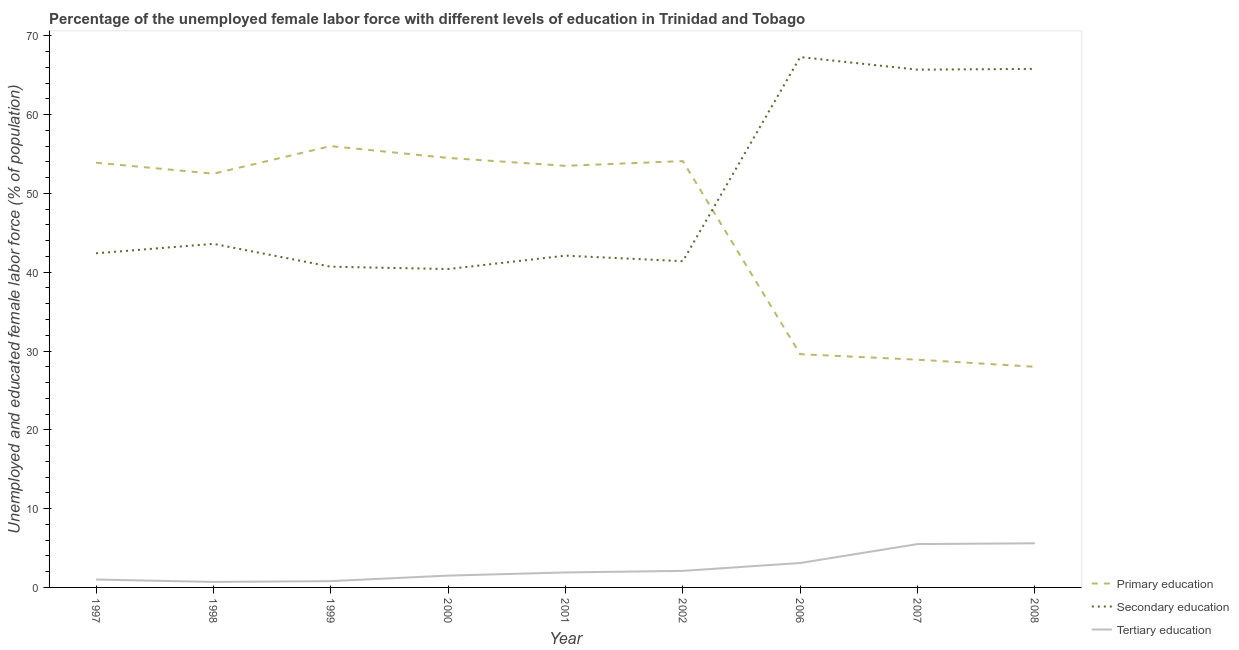How many different coloured lines are there?
Offer a terse response. 3. Does the line corresponding to percentage of female labor force who received tertiary education intersect with the line corresponding to percentage of female labor force who received primary education?
Make the answer very short. No. What is the percentage of female labor force who received tertiary education in 2001?
Give a very brief answer. 1.9. Across all years, what is the maximum percentage of female labor force who received secondary education?
Keep it short and to the point. 67.3. Across all years, what is the minimum percentage of female labor force who received tertiary education?
Keep it short and to the point. 0.7. In which year was the percentage of female labor force who received primary education maximum?
Provide a short and direct response. 1999. In which year was the percentage of female labor force who received secondary education minimum?
Provide a succinct answer. 2000. What is the total percentage of female labor force who received secondary education in the graph?
Ensure brevity in your answer.  449.4. What is the difference between the percentage of female labor force who received tertiary education in 1997 and that in 2007?
Your response must be concise. -4.5. What is the difference between the percentage of female labor force who received secondary education in 2007 and the percentage of female labor force who received primary education in 2001?
Give a very brief answer. 12.2. What is the average percentage of female labor force who received secondary education per year?
Your response must be concise. 49.93. In the year 2000, what is the difference between the percentage of female labor force who received primary education and percentage of female labor force who received secondary education?
Your answer should be very brief. 14.1. What is the ratio of the percentage of female labor force who received tertiary education in 1997 to that in 2001?
Provide a succinct answer. 0.53. Is the percentage of female labor force who received primary education in 1999 less than that in 2007?
Provide a succinct answer. No. What is the difference between the highest and the second highest percentage of female labor force who received secondary education?
Your answer should be very brief. 1.5. What is the difference between the highest and the lowest percentage of female labor force who received secondary education?
Provide a succinct answer. 26.9. In how many years, is the percentage of female labor force who received tertiary education greater than the average percentage of female labor force who received tertiary education taken over all years?
Offer a terse response. 3. Is it the case that in every year, the sum of the percentage of female labor force who received primary education and percentage of female labor force who received secondary education is greater than the percentage of female labor force who received tertiary education?
Your answer should be very brief. Yes. Is the percentage of female labor force who received tertiary education strictly greater than the percentage of female labor force who received primary education over the years?
Make the answer very short. No. Is the percentage of female labor force who received secondary education strictly less than the percentage of female labor force who received primary education over the years?
Provide a short and direct response. No. How many lines are there?
Give a very brief answer. 3. How many years are there in the graph?
Provide a short and direct response. 9. What is the difference between two consecutive major ticks on the Y-axis?
Ensure brevity in your answer.  10. Are the values on the major ticks of Y-axis written in scientific E-notation?
Provide a short and direct response. No. Where does the legend appear in the graph?
Your answer should be very brief. Bottom right. How many legend labels are there?
Your response must be concise. 3. What is the title of the graph?
Keep it short and to the point. Percentage of the unemployed female labor force with different levels of education in Trinidad and Tobago. What is the label or title of the Y-axis?
Provide a succinct answer. Unemployed and educated female labor force (% of population). What is the Unemployed and educated female labor force (% of population) of Primary education in 1997?
Your answer should be very brief. 53.9. What is the Unemployed and educated female labor force (% of population) in Secondary education in 1997?
Keep it short and to the point. 42.4. What is the Unemployed and educated female labor force (% of population) of Primary education in 1998?
Provide a short and direct response. 52.5. What is the Unemployed and educated female labor force (% of population) of Secondary education in 1998?
Make the answer very short. 43.6. What is the Unemployed and educated female labor force (% of population) of Tertiary education in 1998?
Ensure brevity in your answer.  0.7. What is the Unemployed and educated female labor force (% of population) of Primary education in 1999?
Give a very brief answer. 56. What is the Unemployed and educated female labor force (% of population) of Secondary education in 1999?
Give a very brief answer. 40.7. What is the Unemployed and educated female labor force (% of population) of Tertiary education in 1999?
Offer a terse response. 0.8. What is the Unemployed and educated female labor force (% of population) of Primary education in 2000?
Provide a short and direct response. 54.5. What is the Unemployed and educated female labor force (% of population) in Secondary education in 2000?
Make the answer very short. 40.4. What is the Unemployed and educated female labor force (% of population) in Tertiary education in 2000?
Your answer should be compact. 1.5. What is the Unemployed and educated female labor force (% of population) of Primary education in 2001?
Offer a very short reply. 53.5. What is the Unemployed and educated female labor force (% of population) in Secondary education in 2001?
Offer a terse response. 42.1. What is the Unemployed and educated female labor force (% of population) of Tertiary education in 2001?
Your answer should be compact. 1.9. What is the Unemployed and educated female labor force (% of population) of Primary education in 2002?
Provide a short and direct response. 54.1. What is the Unemployed and educated female labor force (% of population) in Secondary education in 2002?
Provide a short and direct response. 41.4. What is the Unemployed and educated female labor force (% of population) of Tertiary education in 2002?
Provide a succinct answer. 2.1. What is the Unemployed and educated female labor force (% of population) of Primary education in 2006?
Provide a succinct answer. 29.6. What is the Unemployed and educated female labor force (% of population) of Secondary education in 2006?
Make the answer very short. 67.3. What is the Unemployed and educated female labor force (% of population) in Tertiary education in 2006?
Provide a short and direct response. 3.1. What is the Unemployed and educated female labor force (% of population) of Primary education in 2007?
Your response must be concise. 28.9. What is the Unemployed and educated female labor force (% of population) in Secondary education in 2007?
Offer a very short reply. 65.7. What is the Unemployed and educated female labor force (% of population) of Secondary education in 2008?
Provide a short and direct response. 65.8. What is the Unemployed and educated female labor force (% of population) of Tertiary education in 2008?
Offer a terse response. 5.6. Across all years, what is the maximum Unemployed and educated female labor force (% of population) of Secondary education?
Provide a short and direct response. 67.3. Across all years, what is the maximum Unemployed and educated female labor force (% of population) of Tertiary education?
Your response must be concise. 5.6. Across all years, what is the minimum Unemployed and educated female labor force (% of population) in Secondary education?
Offer a terse response. 40.4. Across all years, what is the minimum Unemployed and educated female labor force (% of population) of Tertiary education?
Make the answer very short. 0.7. What is the total Unemployed and educated female labor force (% of population) of Primary education in the graph?
Your answer should be very brief. 411. What is the total Unemployed and educated female labor force (% of population) in Secondary education in the graph?
Make the answer very short. 449.4. What is the difference between the Unemployed and educated female labor force (% of population) in Primary education in 1997 and that in 1998?
Offer a very short reply. 1.4. What is the difference between the Unemployed and educated female labor force (% of population) of Tertiary education in 1997 and that in 1998?
Your answer should be very brief. 0.3. What is the difference between the Unemployed and educated female labor force (% of population) in Tertiary education in 1997 and that in 1999?
Provide a short and direct response. 0.2. What is the difference between the Unemployed and educated female labor force (% of population) in Tertiary education in 1997 and that in 2000?
Offer a very short reply. -0.5. What is the difference between the Unemployed and educated female labor force (% of population) of Primary education in 1997 and that in 2006?
Give a very brief answer. 24.3. What is the difference between the Unemployed and educated female labor force (% of population) of Secondary education in 1997 and that in 2006?
Make the answer very short. -24.9. What is the difference between the Unemployed and educated female labor force (% of population) of Tertiary education in 1997 and that in 2006?
Give a very brief answer. -2.1. What is the difference between the Unemployed and educated female labor force (% of population) in Primary education in 1997 and that in 2007?
Offer a very short reply. 25. What is the difference between the Unemployed and educated female labor force (% of population) in Secondary education in 1997 and that in 2007?
Your answer should be very brief. -23.3. What is the difference between the Unemployed and educated female labor force (% of population) in Tertiary education in 1997 and that in 2007?
Offer a very short reply. -4.5. What is the difference between the Unemployed and educated female labor force (% of population) of Primary education in 1997 and that in 2008?
Offer a very short reply. 25.9. What is the difference between the Unemployed and educated female labor force (% of population) of Secondary education in 1997 and that in 2008?
Make the answer very short. -23.4. What is the difference between the Unemployed and educated female labor force (% of population) of Primary education in 1998 and that in 1999?
Provide a succinct answer. -3.5. What is the difference between the Unemployed and educated female labor force (% of population) of Primary education in 1998 and that in 2000?
Provide a short and direct response. -2. What is the difference between the Unemployed and educated female labor force (% of population) in Secondary education in 1998 and that in 2000?
Offer a terse response. 3.2. What is the difference between the Unemployed and educated female labor force (% of population) in Tertiary education in 1998 and that in 2000?
Keep it short and to the point. -0.8. What is the difference between the Unemployed and educated female labor force (% of population) in Secondary education in 1998 and that in 2001?
Provide a succinct answer. 1.5. What is the difference between the Unemployed and educated female labor force (% of population) of Tertiary education in 1998 and that in 2001?
Provide a short and direct response. -1.2. What is the difference between the Unemployed and educated female labor force (% of population) in Secondary education in 1998 and that in 2002?
Provide a succinct answer. 2.2. What is the difference between the Unemployed and educated female labor force (% of population) of Primary education in 1998 and that in 2006?
Provide a succinct answer. 22.9. What is the difference between the Unemployed and educated female labor force (% of population) of Secondary education in 1998 and that in 2006?
Make the answer very short. -23.7. What is the difference between the Unemployed and educated female labor force (% of population) in Primary education in 1998 and that in 2007?
Your response must be concise. 23.6. What is the difference between the Unemployed and educated female labor force (% of population) in Secondary education in 1998 and that in 2007?
Provide a succinct answer. -22.1. What is the difference between the Unemployed and educated female labor force (% of population) in Tertiary education in 1998 and that in 2007?
Keep it short and to the point. -4.8. What is the difference between the Unemployed and educated female labor force (% of population) of Secondary education in 1998 and that in 2008?
Your answer should be very brief. -22.2. What is the difference between the Unemployed and educated female labor force (% of population) of Primary education in 1999 and that in 2000?
Make the answer very short. 1.5. What is the difference between the Unemployed and educated female labor force (% of population) in Secondary education in 1999 and that in 2000?
Give a very brief answer. 0.3. What is the difference between the Unemployed and educated female labor force (% of population) in Tertiary education in 1999 and that in 2000?
Give a very brief answer. -0.7. What is the difference between the Unemployed and educated female labor force (% of population) of Primary education in 1999 and that in 2001?
Provide a succinct answer. 2.5. What is the difference between the Unemployed and educated female labor force (% of population) of Secondary education in 1999 and that in 2001?
Your response must be concise. -1.4. What is the difference between the Unemployed and educated female labor force (% of population) in Tertiary education in 1999 and that in 2002?
Your response must be concise. -1.3. What is the difference between the Unemployed and educated female labor force (% of population) in Primary education in 1999 and that in 2006?
Provide a short and direct response. 26.4. What is the difference between the Unemployed and educated female labor force (% of population) in Secondary education in 1999 and that in 2006?
Ensure brevity in your answer.  -26.6. What is the difference between the Unemployed and educated female labor force (% of population) in Primary education in 1999 and that in 2007?
Provide a succinct answer. 27.1. What is the difference between the Unemployed and educated female labor force (% of population) of Tertiary education in 1999 and that in 2007?
Your answer should be very brief. -4.7. What is the difference between the Unemployed and educated female labor force (% of population) in Secondary education in 1999 and that in 2008?
Ensure brevity in your answer.  -25.1. What is the difference between the Unemployed and educated female labor force (% of population) in Tertiary education in 1999 and that in 2008?
Keep it short and to the point. -4.8. What is the difference between the Unemployed and educated female labor force (% of population) of Tertiary education in 2000 and that in 2002?
Your response must be concise. -0.6. What is the difference between the Unemployed and educated female labor force (% of population) in Primary education in 2000 and that in 2006?
Provide a succinct answer. 24.9. What is the difference between the Unemployed and educated female labor force (% of population) in Secondary education in 2000 and that in 2006?
Give a very brief answer. -26.9. What is the difference between the Unemployed and educated female labor force (% of population) in Primary education in 2000 and that in 2007?
Make the answer very short. 25.6. What is the difference between the Unemployed and educated female labor force (% of population) of Secondary education in 2000 and that in 2007?
Give a very brief answer. -25.3. What is the difference between the Unemployed and educated female labor force (% of population) of Tertiary education in 2000 and that in 2007?
Offer a terse response. -4. What is the difference between the Unemployed and educated female labor force (% of population) in Primary education in 2000 and that in 2008?
Keep it short and to the point. 26.5. What is the difference between the Unemployed and educated female labor force (% of population) in Secondary education in 2000 and that in 2008?
Offer a very short reply. -25.4. What is the difference between the Unemployed and educated female labor force (% of population) of Primary education in 2001 and that in 2002?
Offer a terse response. -0.6. What is the difference between the Unemployed and educated female labor force (% of population) in Secondary education in 2001 and that in 2002?
Offer a very short reply. 0.7. What is the difference between the Unemployed and educated female labor force (% of population) of Primary education in 2001 and that in 2006?
Give a very brief answer. 23.9. What is the difference between the Unemployed and educated female labor force (% of population) in Secondary education in 2001 and that in 2006?
Make the answer very short. -25.2. What is the difference between the Unemployed and educated female labor force (% of population) of Tertiary education in 2001 and that in 2006?
Your response must be concise. -1.2. What is the difference between the Unemployed and educated female labor force (% of population) in Primary education in 2001 and that in 2007?
Keep it short and to the point. 24.6. What is the difference between the Unemployed and educated female labor force (% of population) of Secondary education in 2001 and that in 2007?
Your answer should be compact. -23.6. What is the difference between the Unemployed and educated female labor force (% of population) of Tertiary education in 2001 and that in 2007?
Give a very brief answer. -3.6. What is the difference between the Unemployed and educated female labor force (% of population) of Primary education in 2001 and that in 2008?
Your answer should be compact. 25.5. What is the difference between the Unemployed and educated female labor force (% of population) of Secondary education in 2001 and that in 2008?
Your answer should be very brief. -23.7. What is the difference between the Unemployed and educated female labor force (% of population) in Tertiary education in 2001 and that in 2008?
Make the answer very short. -3.7. What is the difference between the Unemployed and educated female labor force (% of population) in Primary education in 2002 and that in 2006?
Ensure brevity in your answer.  24.5. What is the difference between the Unemployed and educated female labor force (% of population) in Secondary education in 2002 and that in 2006?
Your answer should be very brief. -25.9. What is the difference between the Unemployed and educated female labor force (% of population) of Tertiary education in 2002 and that in 2006?
Your response must be concise. -1. What is the difference between the Unemployed and educated female labor force (% of population) of Primary education in 2002 and that in 2007?
Your response must be concise. 25.2. What is the difference between the Unemployed and educated female labor force (% of population) of Secondary education in 2002 and that in 2007?
Offer a terse response. -24.3. What is the difference between the Unemployed and educated female labor force (% of population) in Primary education in 2002 and that in 2008?
Provide a succinct answer. 26.1. What is the difference between the Unemployed and educated female labor force (% of population) of Secondary education in 2002 and that in 2008?
Provide a succinct answer. -24.4. What is the difference between the Unemployed and educated female labor force (% of population) of Primary education in 2006 and that in 2007?
Offer a very short reply. 0.7. What is the difference between the Unemployed and educated female labor force (% of population) of Secondary education in 2006 and that in 2007?
Provide a succinct answer. 1.6. What is the difference between the Unemployed and educated female labor force (% of population) in Tertiary education in 2006 and that in 2007?
Provide a succinct answer. -2.4. What is the difference between the Unemployed and educated female labor force (% of population) in Primary education in 2006 and that in 2008?
Keep it short and to the point. 1.6. What is the difference between the Unemployed and educated female labor force (% of population) of Primary education in 1997 and the Unemployed and educated female labor force (% of population) of Secondary education in 1998?
Your response must be concise. 10.3. What is the difference between the Unemployed and educated female labor force (% of population) of Primary education in 1997 and the Unemployed and educated female labor force (% of population) of Tertiary education in 1998?
Offer a very short reply. 53.2. What is the difference between the Unemployed and educated female labor force (% of population) in Secondary education in 1997 and the Unemployed and educated female labor force (% of population) in Tertiary education in 1998?
Your response must be concise. 41.7. What is the difference between the Unemployed and educated female labor force (% of population) in Primary education in 1997 and the Unemployed and educated female labor force (% of population) in Tertiary education in 1999?
Ensure brevity in your answer.  53.1. What is the difference between the Unemployed and educated female labor force (% of population) in Secondary education in 1997 and the Unemployed and educated female labor force (% of population) in Tertiary education in 1999?
Your response must be concise. 41.6. What is the difference between the Unemployed and educated female labor force (% of population) of Primary education in 1997 and the Unemployed and educated female labor force (% of population) of Tertiary education in 2000?
Give a very brief answer. 52.4. What is the difference between the Unemployed and educated female labor force (% of population) in Secondary education in 1997 and the Unemployed and educated female labor force (% of population) in Tertiary education in 2000?
Your response must be concise. 40.9. What is the difference between the Unemployed and educated female labor force (% of population) in Secondary education in 1997 and the Unemployed and educated female labor force (% of population) in Tertiary education in 2001?
Ensure brevity in your answer.  40.5. What is the difference between the Unemployed and educated female labor force (% of population) in Primary education in 1997 and the Unemployed and educated female labor force (% of population) in Secondary education in 2002?
Your response must be concise. 12.5. What is the difference between the Unemployed and educated female labor force (% of population) in Primary education in 1997 and the Unemployed and educated female labor force (% of population) in Tertiary education in 2002?
Provide a succinct answer. 51.8. What is the difference between the Unemployed and educated female labor force (% of population) of Secondary education in 1997 and the Unemployed and educated female labor force (% of population) of Tertiary education in 2002?
Your answer should be compact. 40.3. What is the difference between the Unemployed and educated female labor force (% of population) in Primary education in 1997 and the Unemployed and educated female labor force (% of population) in Secondary education in 2006?
Offer a very short reply. -13.4. What is the difference between the Unemployed and educated female labor force (% of population) of Primary education in 1997 and the Unemployed and educated female labor force (% of population) of Tertiary education in 2006?
Your answer should be compact. 50.8. What is the difference between the Unemployed and educated female labor force (% of population) in Secondary education in 1997 and the Unemployed and educated female labor force (% of population) in Tertiary education in 2006?
Keep it short and to the point. 39.3. What is the difference between the Unemployed and educated female labor force (% of population) in Primary education in 1997 and the Unemployed and educated female labor force (% of population) in Tertiary education in 2007?
Offer a very short reply. 48.4. What is the difference between the Unemployed and educated female labor force (% of population) of Secondary education in 1997 and the Unemployed and educated female labor force (% of population) of Tertiary education in 2007?
Give a very brief answer. 36.9. What is the difference between the Unemployed and educated female labor force (% of population) of Primary education in 1997 and the Unemployed and educated female labor force (% of population) of Tertiary education in 2008?
Your answer should be compact. 48.3. What is the difference between the Unemployed and educated female labor force (% of population) of Secondary education in 1997 and the Unemployed and educated female labor force (% of population) of Tertiary education in 2008?
Give a very brief answer. 36.8. What is the difference between the Unemployed and educated female labor force (% of population) in Primary education in 1998 and the Unemployed and educated female labor force (% of population) in Tertiary education in 1999?
Provide a short and direct response. 51.7. What is the difference between the Unemployed and educated female labor force (% of population) of Secondary education in 1998 and the Unemployed and educated female labor force (% of population) of Tertiary education in 1999?
Give a very brief answer. 42.8. What is the difference between the Unemployed and educated female labor force (% of population) in Primary education in 1998 and the Unemployed and educated female labor force (% of population) in Secondary education in 2000?
Provide a succinct answer. 12.1. What is the difference between the Unemployed and educated female labor force (% of population) in Primary education in 1998 and the Unemployed and educated female labor force (% of population) in Tertiary education in 2000?
Offer a terse response. 51. What is the difference between the Unemployed and educated female labor force (% of population) of Secondary education in 1998 and the Unemployed and educated female labor force (% of population) of Tertiary education in 2000?
Ensure brevity in your answer.  42.1. What is the difference between the Unemployed and educated female labor force (% of population) in Primary education in 1998 and the Unemployed and educated female labor force (% of population) in Secondary education in 2001?
Provide a short and direct response. 10.4. What is the difference between the Unemployed and educated female labor force (% of population) of Primary education in 1998 and the Unemployed and educated female labor force (% of population) of Tertiary education in 2001?
Your response must be concise. 50.6. What is the difference between the Unemployed and educated female labor force (% of population) of Secondary education in 1998 and the Unemployed and educated female labor force (% of population) of Tertiary education in 2001?
Ensure brevity in your answer.  41.7. What is the difference between the Unemployed and educated female labor force (% of population) in Primary education in 1998 and the Unemployed and educated female labor force (% of population) in Tertiary education in 2002?
Offer a very short reply. 50.4. What is the difference between the Unemployed and educated female labor force (% of population) of Secondary education in 1998 and the Unemployed and educated female labor force (% of population) of Tertiary education in 2002?
Give a very brief answer. 41.5. What is the difference between the Unemployed and educated female labor force (% of population) of Primary education in 1998 and the Unemployed and educated female labor force (% of population) of Secondary education in 2006?
Your answer should be compact. -14.8. What is the difference between the Unemployed and educated female labor force (% of population) of Primary education in 1998 and the Unemployed and educated female labor force (% of population) of Tertiary education in 2006?
Offer a very short reply. 49.4. What is the difference between the Unemployed and educated female labor force (% of population) in Secondary education in 1998 and the Unemployed and educated female labor force (% of population) in Tertiary education in 2006?
Provide a short and direct response. 40.5. What is the difference between the Unemployed and educated female labor force (% of population) in Primary education in 1998 and the Unemployed and educated female labor force (% of population) in Secondary education in 2007?
Provide a short and direct response. -13.2. What is the difference between the Unemployed and educated female labor force (% of population) in Secondary education in 1998 and the Unemployed and educated female labor force (% of population) in Tertiary education in 2007?
Make the answer very short. 38.1. What is the difference between the Unemployed and educated female labor force (% of population) in Primary education in 1998 and the Unemployed and educated female labor force (% of population) in Secondary education in 2008?
Your response must be concise. -13.3. What is the difference between the Unemployed and educated female labor force (% of population) of Primary education in 1998 and the Unemployed and educated female labor force (% of population) of Tertiary education in 2008?
Make the answer very short. 46.9. What is the difference between the Unemployed and educated female labor force (% of population) of Secondary education in 1998 and the Unemployed and educated female labor force (% of population) of Tertiary education in 2008?
Provide a succinct answer. 38. What is the difference between the Unemployed and educated female labor force (% of population) in Primary education in 1999 and the Unemployed and educated female labor force (% of population) in Tertiary education in 2000?
Ensure brevity in your answer.  54.5. What is the difference between the Unemployed and educated female labor force (% of population) of Secondary education in 1999 and the Unemployed and educated female labor force (% of population) of Tertiary education in 2000?
Ensure brevity in your answer.  39.2. What is the difference between the Unemployed and educated female labor force (% of population) of Primary education in 1999 and the Unemployed and educated female labor force (% of population) of Tertiary education in 2001?
Your answer should be very brief. 54.1. What is the difference between the Unemployed and educated female labor force (% of population) in Secondary education in 1999 and the Unemployed and educated female labor force (% of population) in Tertiary education in 2001?
Make the answer very short. 38.8. What is the difference between the Unemployed and educated female labor force (% of population) in Primary education in 1999 and the Unemployed and educated female labor force (% of population) in Tertiary education in 2002?
Ensure brevity in your answer.  53.9. What is the difference between the Unemployed and educated female labor force (% of population) in Secondary education in 1999 and the Unemployed and educated female labor force (% of population) in Tertiary education in 2002?
Make the answer very short. 38.6. What is the difference between the Unemployed and educated female labor force (% of population) of Primary education in 1999 and the Unemployed and educated female labor force (% of population) of Tertiary education in 2006?
Make the answer very short. 52.9. What is the difference between the Unemployed and educated female labor force (% of population) of Secondary education in 1999 and the Unemployed and educated female labor force (% of population) of Tertiary education in 2006?
Offer a terse response. 37.6. What is the difference between the Unemployed and educated female labor force (% of population) of Primary education in 1999 and the Unemployed and educated female labor force (% of population) of Tertiary education in 2007?
Your answer should be very brief. 50.5. What is the difference between the Unemployed and educated female labor force (% of population) in Secondary education in 1999 and the Unemployed and educated female labor force (% of population) in Tertiary education in 2007?
Ensure brevity in your answer.  35.2. What is the difference between the Unemployed and educated female labor force (% of population) in Primary education in 1999 and the Unemployed and educated female labor force (% of population) in Tertiary education in 2008?
Keep it short and to the point. 50.4. What is the difference between the Unemployed and educated female labor force (% of population) in Secondary education in 1999 and the Unemployed and educated female labor force (% of population) in Tertiary education in 2008?
Offer a very short reply. 35.1. What is the difference between the Unemployed and educated female labor force (% of population) of Primary education in 2000 and the Unemployed and educated female labor force (% of population) of Secondary education in 2001?
Your answer should be very brief. 12.4. What is the difference between the Unemployed and educated female labor force (% of population) in Primary education in 2000 and the Unemployed and educated female labor force (% of population) in Tertiary education in 2001?
Provide a short and direct response. 52.6. What is the difference between the Unemployed and educated female labor force (% of population) in Secondary education in 2000 and the Unemployed and educated female labor force (% of population) in Tertiary education in 2001?
Ensure brevity in your answer.  38.5. What is the difference between the Unemployed and educated female labor force (% of population) of Primary education in 2000 and the Unemployed and educated female labor force (% of population) of Secondary education in 2002?
Your answer should be compact. 13.1. What is the difference between the Unemployed and educated female labor force (% of population) in Primary education in 2000 and the Unemployed and educated female labor force (% of population) in Tertiary education in 2002?
Ensure brevity in your answer.  52.4. What is the difference between the Unemployed and educated female labor force (% of population) of Secondary education in 2000 and the Unemployed and educated female labor force (% of population) of Tertiary education in 2002?
Your response must be concise. 38.3. What is the difference between the Unemployed and educated female labor force (% of population) of Primary education in 2000 and the Unemployed and educated female labor force (% of population) of Tertiary education in 2006?
Give a very brief answer. 51.4. What is the difference between the Unemployed and educated female labor force (% of population) of Secondary education in 2000 and the Unemployed and educated female labor force (% of population) of Tertiary education in 2006?
Your response must be concise. 37.3. What is the difference between the Unemployed and educated female labor force (% of population) in Primary education in 2000 and the Unemployed and educated female labor force (% of population) in Tertiary education in 2007?
Your response must be concise. 49. What is the difference between the Unemployed and educated female labor force (% of population) of Secondary education in 2000 and the Unemployed and educated female labor force (% of population) of Tertiary education in 2007?
Provide a short and direct response. 34.9. What is the difference between the Unemployed and educated female labor force (% of population) of Primary education in 2000 and the Unemployed and educated female labor force (% of population) of Secondary education in 2008?
Ensure brevity in your answer.  -11.3. What is the difference between the Unemployed and educated female labor force (% of population) of Primary education in 2000 and the Unemployed and educated female labor force (% of population) of Tertiary education in 2008?
Your answer should be compact. 48.9. What is the difference between the Unemployed and educated female labor force (% of population) of Secondary education in 2000 and the Unemployed and educated female labor force (% of population) of Tertiary education in 2008?
Your response must be concise. 34.8. What is the difference between the Unemployed and educated female labor force (% of population) in Primary education in 2001 and the Unemployed and educated female labor force (% of population) in Secondary education in 2002?
Make the answer very short. 12.1. What is the difference between the Unemployed and educated female labor force (% of population) of Primary education in 2001 and the Unemployed and educated female labor force (% of population) of Tertiary education in 2002?
Give a very brief answer. 51.4. What is the difference between the Unemployed and educated female labor force (% of population) of Secondary education in 2001 and the Unemployed and educated female labor force (% of population) of Tertiary education in 2002?
Offer a terse response. 40. What is the difference between the Unemployed and educated female labor force (% of population) of Primary education in 2001 and the Unemployed and educated female labor force (% of population) of Secondary education in 2006?
Keep it short and to the point. -13.8. What is the difference between the Unemployed and educated female labor force (% of population) in Primary education in 2001 and the Unemployed and educated female labor force (% of population) in Tertiary education in 2006?
Make the answer very short. 50.4. What is the difference between the Unemployed and educated female labor force (% of population) in Secondary education in 2001 and the Unemployed and educated female labor force (% of population) in Tertiary education in 2006?
Keep it short and to the point. 39. What is the difference between the Unemployed and educated female labor force (% of population) in Primary education in 2001 and the Unemployed and educated female labor force (% of population) in Tertiary education in 2007?
Your response must be concise. 48. What is the difference between the Unemployed and educated female labor force (% of population) of Secondary education in 2001 and the Unemployed and educated female labor force (% of population) of Tertiary education in 2007?
Keep it short and to the point. 36.6. What is the difference between the Unemployed and educated female labor force (% of population) of Primary education in 2001 and the Unemployed and educated female labor force (% of population) of Tertiary education in 2008?
Provide a short and direct response. 47.9. What is the difference between the Unemployed and educated female labor force (% of population) in Secondary education in 2001 and the Unemployed and educated female labor force (% of population) in Tertiary education in 2008?
Your answer should be compact. 36.5. What is the difference between the Unemployed and educated female labor force (% of population) of Primary education in 2002 and the Unemployed and educated female labor force (% of population) of Tertiary education in 2006?
Offer a terse response. 51. What is the difference between the Unemployed and educated female labor force (% of population) of Secondary education in 2002 and the Unemployed and educated female labor force (% of population) of Tertiary education in 2006?
Make the answer very short. 38.3. What is the difference between the Unemployed and educated female labor force (% of population) in Primary education in 2002 and the Unemployed and educated female labor force (% of population) in Tertiary education in 2007?
Your answer should be compact. 48.6. What is the difference between the Unemployed and educated female labor force (% of population) of Secondary education in 2002 and the Unemployed and educated female labor force (% of population) of Tertiary education in 2007?
Ensure brevity in your answer.  35.9. What is the difference between the Unemployed and educated female labor force (% of population) of Primary education in 2002 and the Unemployed and educated female labor force (% of population) of Secondary education in 2008?
Ensure brevity in your answer.  -11.7. What is the difference between the Unemployed and educated female labor force (% of population) in Primary education in 2002 and the Unemployed and educated female labor force (% of population) in Tertiary education in 2008?
Provide a short and direct response. 48.5. What is the difference between the Unemployed and educated female labor force (% of population) of Secondary education in 2002 and the Unemployed and educated female labor force (% of population) of Tertiary education in 2008?
Provide a succinct answer. 35.8. What is the difference between the Unemployed and educated female labor force (% of population) in Primary education in 2006 and the Unemployed and educated female labor force (% of population) in Secondary education in 2007?
Provide a succinct answer. -36.1. What is the difference between the Unemployed and educated female labor force (% of population) of Primary education in 2006 and the Unemployed and educated female labor force (% of population) of Tertiary education in 2007?
Keep it short and to the point. 24.1. What is the difference between the Unemployed and educated female labor force (% of population) in Secondary education in 2006 and the Unemployed and educated female labor force (% of population) in Tertiary education in 2007?
Offer a very short reply. 61.8. What is the difference between the Unemployed and educated female labor force (% of population) of Primary education in 2006 and the Unemployed and educated female labor force (% of population) of Secondary education in 2008?
Provide a succinct answer. -36.2. What is the difference between the Unemployed and educated female labor force (% of population) of Primary education in 2006 and the Unemployed and educated female labor force (% of population) of Tertiary education in 2008?
Make the answer very short. 24. What is the difference between the Unemployed and educated female labor force (% of population) in Secondary education in 2006 and the Unemployed and educated female labor force (% of population) in Tertiary education in 2008?
Provide a succinct answer. 61.7. What is the difference between the Unemployed and educated female labor force (% of population) of Primary education in 2007 and the Unemployed and educated female labor force (% of population) of Secondary education in 2008?
Give a very brief answer. -36.9. What is the difference between the Unemployed and educated female labor force (% of population) in Primary education in 2007 and the Unemployed and educated female labor force (% of population) in Tertiary education in 2008?
Keep it short and to the point. 23.3. What is the difference between the Unemployed and educated female labor force (% of population) in Secondary education in 2007 and the Unemployed and educated female labor force (% of population) in Tertiary education in 2008?
Your response must be concise. 60.1. What is the average Unemployed and educated female labor force (% of population) in Primary education per year?
Your answer should be very brief. 45.67. What is the average Unemployed and educated female labor force (% of population) of Secondary education per year?
Offer a terse response. 49.93. What is the average Unemployed and educated female labor force (% of population) of Tertiary education per year?
Offer a terse response. 2.47. In the year 1997, what is the difference between the Unemployed and educated female labor force (% of population) of Primary education and Unemployed and educated female labor force (% of population) of Tertiary education?
Your response must be concise. 52.9. In the year 1997, what is the difference between the Unemployed and educated female labor force (% of population) of Secondary education and Unemployed and educated female labor force (% of population) of Tertiary education?
Your answer should be compact. 41.4. In the year 1998, what is the difference between the Unemployed and educated female labor force (% of population) of Primary education and Unemployed and educated female labor force (% of population) of Secondary education?
Offer a terse response. 8.9. In the year 1998, what is the difference between the Unemployed and educated female labor force (% of population) of Primary education and Unemployed and educated female labor force (% of population) of Tertiary education?
Your response must be concise. 51.8. In the year 1998, what is the difference between the Unemployed and educated female labor force (% of population) in Secondary education and Unemployed and educated female labor force (% of population) in Tertiary education?
Offer a terse response. 42.9. In the year 1999, what is the difference between the Unemployed and educated female labor force (% of population) in Primary education and Unemployed and educated female labor force (% of population) in Secondary education?
Your answer should be very brief. 15.3. In the year 1999, what is the difference between the Unemployed and educated female labor force (% of population) of Primary education and Unemployed and educated female labor force (% of population) of Tertiary education?
Provide a short and direct response. 55.2. In the year 1999, what is the difference between the Unemployed and educated female labor force (% of population) in Secondary education and Unemployed and educated female labor force (% of population) in Tertiary education?
Give a very brief answer. 39.9. In the year 2000, what is the difference between the Unemployed and educated female labor force (% of population) in Secondary education and Unemployed and educated female labor force (% of population) in Tertiary education?
Offer a very short reply. 38.9. In the year 2001, what is the difference between the Unemployed and educated female labor force (% of population) of Primary education and Unemployed and educated female labor force (% of population) of Secondary education?
Keep it short and to the point. 11.4. In the year 2001, what is the difference between the Unemployed and educated female labor force (% of population) of Primary education and Unemployed and educated female labor force (% of population) of Tertiary education?
Ensure brevity in your answer.  51.6. In the year 2001, what is the difference between the Unemployed and educated female labor force (% of population) of Secondary education and Unemployed and educated female labor force (% of population) of Tertiary education?
Ensure brevity in your answer.  40.2. In the year 2002, what is the difference between the Unemployed and educated female labor force (% of population) of Primary education and Unemployed and educated female labor force (% of population) of Secondary education?
Your response must be concise. 12.7. In the year 2002, what is the difference between the Unemployed and educated female labor force (% of population) in Secondary education and Unemployed and educated female labor force (% of population) in Tertiary education?
Ensure brevity in your answer.  39.3. In the year 2006, what is the difference between the Unemployed and educated female labor force (% of population) of Primary education and Unemployed and educated female labor force (% of population) of Secondary education?
Make the answer very short. -37.7. In the year 2006, what is the difference between the Unemployed and educated female labor force (% of population) in Primary education and Unemployed and educated female labor force (% of population) in Tertiary education?
Provide a succinct answer. 26.5. In the year 2006, what is the difference between the Unemployed and educated female labor force (% of population) of Secondary education and Unemployed and educated female labor force (% of population) of Tertiary education?
Provide a short and direct response. 64.2. In the year 2007, what is the difference between the Unemployed and educated female labor force (% of population) in Primary education and Unemployed and educated female labor force (% of population) in Secondary education?
Give a very brief answer. -36.8. In the year 2007, what is the difference between the Unemployed and educated female labor force (% of population) in Primary education and Unemployed and educated female labor force (% of population) in Tertiary education?
Ensure brevity in your answer.  23.4. In the year 2007, what is the difference between the Unemployed and educated female labor force (% of population) in Secondary education and Unemployed and educated female labor force (% of population) in Tertiary education?
Make the answer very short. 60.2. In the year 2008, what is the difference between the Unemployed and educated female labor force (% of population) in Primary education and Unemployed and educated female labor force (% of population) in Secondary education?
Offer a very short reply. -37.8. In the year 2008, what is the difference between the Unemployed and educated female labor force (% of population) of Primary education and Unemployed and educated female labor force (% of population) of Tertiary education?
Provide a short and direct response. 22.4. In the year 2008, what is the difference between the Unemployed and educated female labor force (% of population) of Secondary education and Unemployed and educated female labor force (% of population) of Tertiary education?
Your response must be concise. 60.2. What is the ratio of the Unemployed and educated female labor force (% of population) in Primary education in 1997 to that in 1998?
Offer a very short reply. 1.03. What is the ratio of the Unemployed and educated female labor force (% of population) of Secondary education in 1997 to that in 1998?
Provide a short and direct response. 0.97. What is the ratio of the Unemployed and educated female labor force (% of population) of Tertiary education in 1997 to that in 1998?
Provide a short and direct response. 1.43. What is the ratio of the Unemployed and educated female labor force (% of population) of Primary education in 1997 to that in 1999?
Give a very brief answer. 0.96. What is the ratio of the Unemployed and educated female labor force (% of population) in Secondary education in 1997 to that in 1999?
Give a very brief answer. 1.04. What is the ratio of the Unemployed and educated female labor force (% of population) of Tertiary education in 1997 to that in 1999?
Make the answer very short. 1.25. What is the ratio of the Unemployed and educated female labor force (% of population) in Secondary education in 1997 to that in 2000?
Give a very brief answer. 1.05. What is the ratio of the Unemployed and educated female labor force (% of population) of Primary education in 1997 to that in 2001?
Make the answer very short. 1.01. What is the ratio of the Unemployed and educated female labor force (% of population) in Secondary education in 1997 to that in 2001?
Offer a very short reply. 1.01. What is the ratio of the Unemployed and educated female labor force (% of population) of Tertiary education in 1997 to that in 2001?
Make the answer very short. 0.53. What is the ratio of the Unemployed and educated female labor force (% of population) of Primary education in 1997 to that in 2002?
Your answer should be compact. 1. What is the ratio of the Unemployed and educated female labor force (% of population) of Secondary education in 1997 to that in 2002?
Keep it short and to the point. 1.02. What is the ratio of the Unemployed and educated female labor force (% of population) in Tertiary education in 1997 to that in 2002?
Provide a succinct answer. 0.48. What is the ratio of the Unemployed and educated female labor force (% of population) of Primary education in 1997 to that in 2006?
Provide a short and direct response. 1.82. What is the ratio of the Unemployed and educated female labor force (% of population) in Secondary education in 1997 to that in 2006?
Make the answer very short. 0.63. What is the ratio of the Unemployed and educated female labor force (% of population) of Tertiary education in 1997 to that in 2006?
Provide a succinct answer. 0.32. What is the ratio of the Unemployed and educated female labor force (% of population) in Primary education in 1997 to that in 2007?
Your answer should be compact. 1.87. What is the ratio of the Unemployed and educated female labor force (% of population) in Secondary education in 1997 to that in 2007?
Your answer should be very brief. 0.65. What is the ratio of the Unemployed and educated female labor force (% of population) of Tertiary education in 1997 to that in 2007?
Keep it short and to the point. 0.18. What is the ratio of the Unemployed and educated female labor force (% of population) in Primary education in 1997 to that in 2008?
Keep it short and to the point. 1.93. What is the ratio of the Unemployed and educated female labor force (% of population) of Secondary education in 1997 to that in 2008?
Ensure brevity in your answer.  0.64. What is the ratio of the Unemployed and educated female labor force (% of population) in Tertiary education in 1997 to that in 2008?
Give a very brief answer. 0.18. What is the ratio of the Unemployed and educated female labor force (% of population) of Primary education in 1998 to that in 1999?
Ensure brevity in your answer.  0.94. What is the ratio of the Unemployed and educated female labor force (% of population) in Secondary education in 1998 to that in 1999?
Provide a short and direct response. 1.07. What is the ratio of the Unemployed and educated female labor force (% of population) of Primary education in 1998 to that in 2000?
Keep it short and to the point. 0.96. What is the ratio of the Unemployed and educated female labor force (% of population) of Secondary education in 1998 to that in 2000?
Provide a succinct answer. 1.08. What is the ratio of the Unemployed and educated female labor force (% of population) in Tertiary education in 1998 to that in 2000?
Ensure brevity in your answer.  0.47. What is the ratio of the Unemployed and educated female labor force (% of population) in Primary education in 1998 to that in 2001?
Give a very brief answer. 0.98. What is the ratio of the Unemployed and educated female labor force (% of population) of Secondary education in 1998 to that in 2001?
Keep it short and to the point. 1.04. What is the ratio of the Unemployed and educated female labor force (% of population) in Tertiary education in 1998 to that in 2001?
Ensure brevity in your answer.  0.37. What is the ratio of the Unemployed and educated female labor force (% of population) in Primary education in 1998 to that in 2002?
Offer a very short reply. 0.97. What is the ratio of the Unemployed and educated female labor force (% of population) of Secondary education in 1998 to that in 2002?
Give a very brief answer. 1.05. What is the ratio of the Unemployed and educated female labor force (% of population) of Primary education in 1998 to that in 2006?
Make the answer very short. 1.77. What is the ratio of the Unemployed and educated female labor force (% of population) of Secondary education in 1998 to that in 2006?
Keep it short and to the point. 0.65. What is the ratio of the Unemployed and educated female labor force (% of population) of Tertiary education in 1998 to that in 2006?
Your answer should be very brief. 0.23. What is the ratio of the Unemployed and educated female labor force (% of population) in Primary education in 1998 to that in 2007?
Your response must be concise. 1.82. What is the ratio of the Unemployed and educated female labor force (% of population) in Secondary education in 1998 to that in 2007?
Your response must be concise. 0.66. What is the ratio of the Unemployed and educated female labor force (% of population) of Tertiary education in 1998 to that in 2007?
Make the answer very short. 0.13. What is the ratio of the Unemployed and educated female labor force (% of population) in Primary education in 1998 to that in 2008?
Ensure brevity in your answer.  1.88. What is the ratio of the Unemployed and educated female labor force (% of population) in Secondary education in 1998 to that in 2008?
Provide a succinct answer. 0.66. What is the ratio of the Unemployed and educated female labor force (% of population) of Primary education in 1999 to that in 2000?
Provide a succinct answer. 1.03. What is the ratio of the Unemployed and educated female labor force (% of population) of Secondary education in 1999 to that in 2000?
Provide a succinct answer. 1.01. What is the ratio of the Unemployed and educated female labor force (% of population) in Tertiary education in 1999 to that in 2000?
Keep it short and to the point. 0.53. What is the ratio of the Unemployed and educated female labor force (% of population) of Primary education in 1999 to that in 2001?
Give a very brief answer. 1.05. What is the ratio of the Unemployed and educated female labor force (% of population) in Secondary education in 1999 to that in 2001?
Your answer should be very brief. 0.97. What is the ratio of the Unemployed and educated female labor force (% of population) of Tertiary education in 1999 to that in 2001?
Ensure brevity in your answer.  0.42. What is the ratio of the Unemployed and educated female labor force (% of population) in Primary education in 1999 to that in 2002?
Your answer should be very brief. 1.04. What is the ratio of the Unemployed and educated female labor force (% of population) in Secondary education in 1999 to that in 2002?
Your answer should be compact. 0.98. What is the ratio of the Unemployed and educated female labor force (% of population) of Tertiary education in 1999 to that in 2002?
Offer a terse response. 0.38. What is the ratio of the Unemployed and educated female labor force (% of population) of Primary education in 1999 to that in 2006?
Offer a very short reply. 1.89. What is the ratio of the Unemployed and educated female labor force (% of population) in Secondary education in 1999 to that in 2006?
Offer a very short reply. 0.6. What is the ratio of the Unemployed and educated female labor force (% of population) in Tertiary education in 1999 to that in 2006?
Make the answer very short. 0.26. What is the ratio of the Unemployed and educated female labor force (% of population) of Primary education in 1999 to that in 2007?
Your answer should be compact. 1.94. What is the ratio of the Unemployed and educated female labor force (% of population) in Secondary education in 1999 to that in 2007?
Ensure brevity in your answer.  0.62. What is the ratio of the Unemployed and educated female labor force (% of population) of Tertiary education in 1999 to that in 2007?
Keep it short and to the point. 0.15. What is the ratio of the Unemployed and educated female labor force (% of population) in Primary education in 1999 to that in 2008?
Keep it short and to the point. 2. What is the ratio of the Unemployed and educated female labor force (% of population) of Secondary education in 1999 to that in 2008?
Keep it short and to the point. 0.62. What is the ratio of the Unemployed and educated female labor force (% of population) in Tertiary education in 1999 to that in 2008?
Your answer should be compact. 0.14. What is the ratio of the Unemployed and educated female labor force (% of population) of Primary education in 2000 to that in 2001?
Provide a succinct answer. 1.02. What is the ratio of the Unemployed and educated female labor force (% of population) of Secondary education in 2000 to that in 2001?
Provide a short and direct response. 0.96. What is the ratio of the Unemployed and educated female labor force (% of population) in Tertiary education in 2000 to that in 2001?
Provide a succinct answer. 0.79. What is the ratio of the Unemployed and educated female labor force (% of population) of Primary education in 2000 to that in 2002?
Keep it short and to the point. 1.01. What is the ratio of the Unemployed and educated female labor force (% of population) in Secondary education in 2000 to that in 2002?
Your answer should be compact. 0.98. What is the ratio of the Unemployed and educated female labor force (% of population) of Tertiary education in 2000 to that in 2002?
Your response must be concise. 0.71. What is the ratio of the Unemployed and educated female labor force (% of population) of Primary education in 2000 to that in 2006?
Your answer should be very brief. 1.84. What is the ratio of the Unemployed and educated female labor force (% of population) of Secondary education in 2000 to that in 2006?
Your answer should be very brief. 0.6. What is the ratio of the Unemployed and educated female labor force (% of population) of Tertiary education in 2000 to that in 2006?
Offer a terse response. 0.48. What is the ratio of the Unemployed and educated female labor force (% of population) in Primary education in 2000 to that in 2007?
Offer a very short reply. 1.89. What is the ratio of the Unemployed and educated female labor force (% of population) of Secondary education in 2000 to that in 2007?
Offer a terse response. 0.61. What is the ratio of the Unemployed and educated female labor force (% of population) of Tertiary education in 2000 to that in 2007?
Give a very brief answer. 0.27. What is the ratio of the Unemployed and educated female labor force (% of population) in Primary education in 2000 to that in 2008?
Your response must be concise. 1.95. What is the ratio of the Unemployed and educated female labor force (% of population) of Secondary education in 2000 to that in 2008?
Make the answer very short. 0.61. What is the ratio of the Unemployed and educated female labor force (% of population) in Tertiary education in 2000 to that in 2008?
Keep it short and to the point. 0.27. What is the ratio of the Unemployed and educated female labor force (% of population) in Primary education in 2001 to that in 2002?
Offer a very short reply. 0.99. What is the ratio of the Unemployed and educated female labor force (% of population) of Secondary education in 2001 to that in 2002?
Ensure brevity in your answer.  1.02. What is the ratio of the Unemployed and educated female labor force (% of population) of Tertiary education in 2001 to that in 2002?
Provide a short and direct response. 0.9. What is the ratio of the Unemployed and educated female labor force (% of population) of Primary education in 2001 to that in 2006?
Provide a succinct answer. 1.81. What is the ratio of the Unemployed and educated female labor force (% of population) in Secondary education in 2001 to that in 2006?
Provide a succinct answer. 0.63. What is the ratio of the Unemployed and educated female labor force (% of population) in Tertiary education in 2001 to that in 2006?
Provide a short and direct response. 0.61. What is the ratio of the Unemployed and educated female labor force (% of population) of Primary education in 2001 to that in 2007?
Offer a terse response. 1.85. What is the ratio of the Unemployed and educated female labor force (% of population) in Secondary education in 2001 to that in 2007?
Your answer should be very brief. 0.64. What is the ratio of the Unemployed and educated female labor force (% of population) of Tertiary education in 2001 to that in 2007?
Offer a very short reply. 0.35. What is the ratio of the Unemployed and educated female labor force (% of population) of Primary education in 2001 to that in 2008?
Provide a short and direct response. 1.91. What is the ratio of the Unemployed and educated female labor force (% of population) of Secondary education in 2001 to that in 2008?
Your answer should be very brief. 0.64. What is the ratio of the Unemployed and educated female labor force (% of population) of Tertiary education in 2001 to that in 2008?
Provide a succinct answer. 0.34. What is the ratio of the Unemployed and educated female labor force (% of population) of Primary education in 2002 to that in 2006?
Offer a very short reply. 1.83. What is the ratio of the Unemployed and educated female labor force (% of population) of Secondary education in 2002 to that in 2006?
Offer a terse response. 0.62. What is the ratio of the Unemployed and educated female labor force (% of population) of Tertiary education in 2002 to that in 2006?
Offer a terse response. 0.68. What is the ratio of the Unemployed and educated female labor force (% of population) of Primary education in 2002 to that in 2007?
Your answer should be compact. 1.87. What is the ratio of the Unemployed and educated female labor force (% of population) of Secondary education in 2002 to that in 2007?
Provide a succinct answer. 0.63. What is the ratio of the Unemployed and educated female labor force (% of population) in Tertiary education in 2002 to that in 2007?
Keep it short and to the point. 0.38. What is the ratio of the Unemployed and educated female labor force (% of population) of Primary education in 2002 to that in 2008?
Give a very brief answer. 1.93. What is the ratio of the Unemployed and educated female labor force (% of population) in Secondary education in 2002 to that in 2008?
Offer a terse response. 0.63. What is the ratio of the Unemployed and educated female labor force (% of population) of Tertiary education in 2002 to that in 2008?
Your response must be concise. 0.38. What is the ratio of the Unemployed and educated female labor force (% of population) of Primary education in 2006 to that in 2007?
Your answer should be compact. 1.02. What is the ratio of the Unemployed and educated female labor force (% of population) in Secondary education in 2006 to that in 2007?
Your answer should be compact. 1.02. What is the ratio of the Unemployed and educated female labor force (% of population) of Tertiary education in 2006 to that in 2007?
Offer a terse response. 0.56. What is the ratio of the Unemployed and educated female labor force (% of population) in Primary education in 2006 to that in 2008?
Give a very brief answer. 1.06. What is the ratio of the Unemployed and educated female labor force (% of population) of Secondary education in 2006 to that in 2008?
Provide a succinct answer. 1.02. What is the ratio of the Unemployed and educated female labor force (% of population) in Tertiary education in 2006 to that in 2008?
Offer a terse response. 0.55. What is the ratio of the Unemployed and educated female labor force (% of population) in Primary education in 2007 to that in 2008?
Offer a terse response. 1.03. What is the ratio of the Unemployed and educated female labor force (% of population) in Secondary education in 2007 to that in 2008?
Your answer should be compact. 1. What is the ratio of the Unemployed and educated female labor force (% of population) of Tertiary education in 2007 to that in 2008?
Keep it short and to the point. 0.98. What is the difference between the highest and the second highest Unemployed and educated female labor force (% of population) of Secondary education?
Ensure brevity in your answer.  1.5. What is the difference between the highest and the lowest Unemployed and educated female labor force (% of population) of Primary education?
Offer a terse response. 28. What is the difference between the highest and the lowest Unemployed and educated female labor force (% of population) in Secondary education?
Your answer should be very brief. 26.9. What is the difference between the highest and the lowest Unemployed and educated female labor force (% of population) in Tertiary education?
Your answer should be compact. 4.9. 